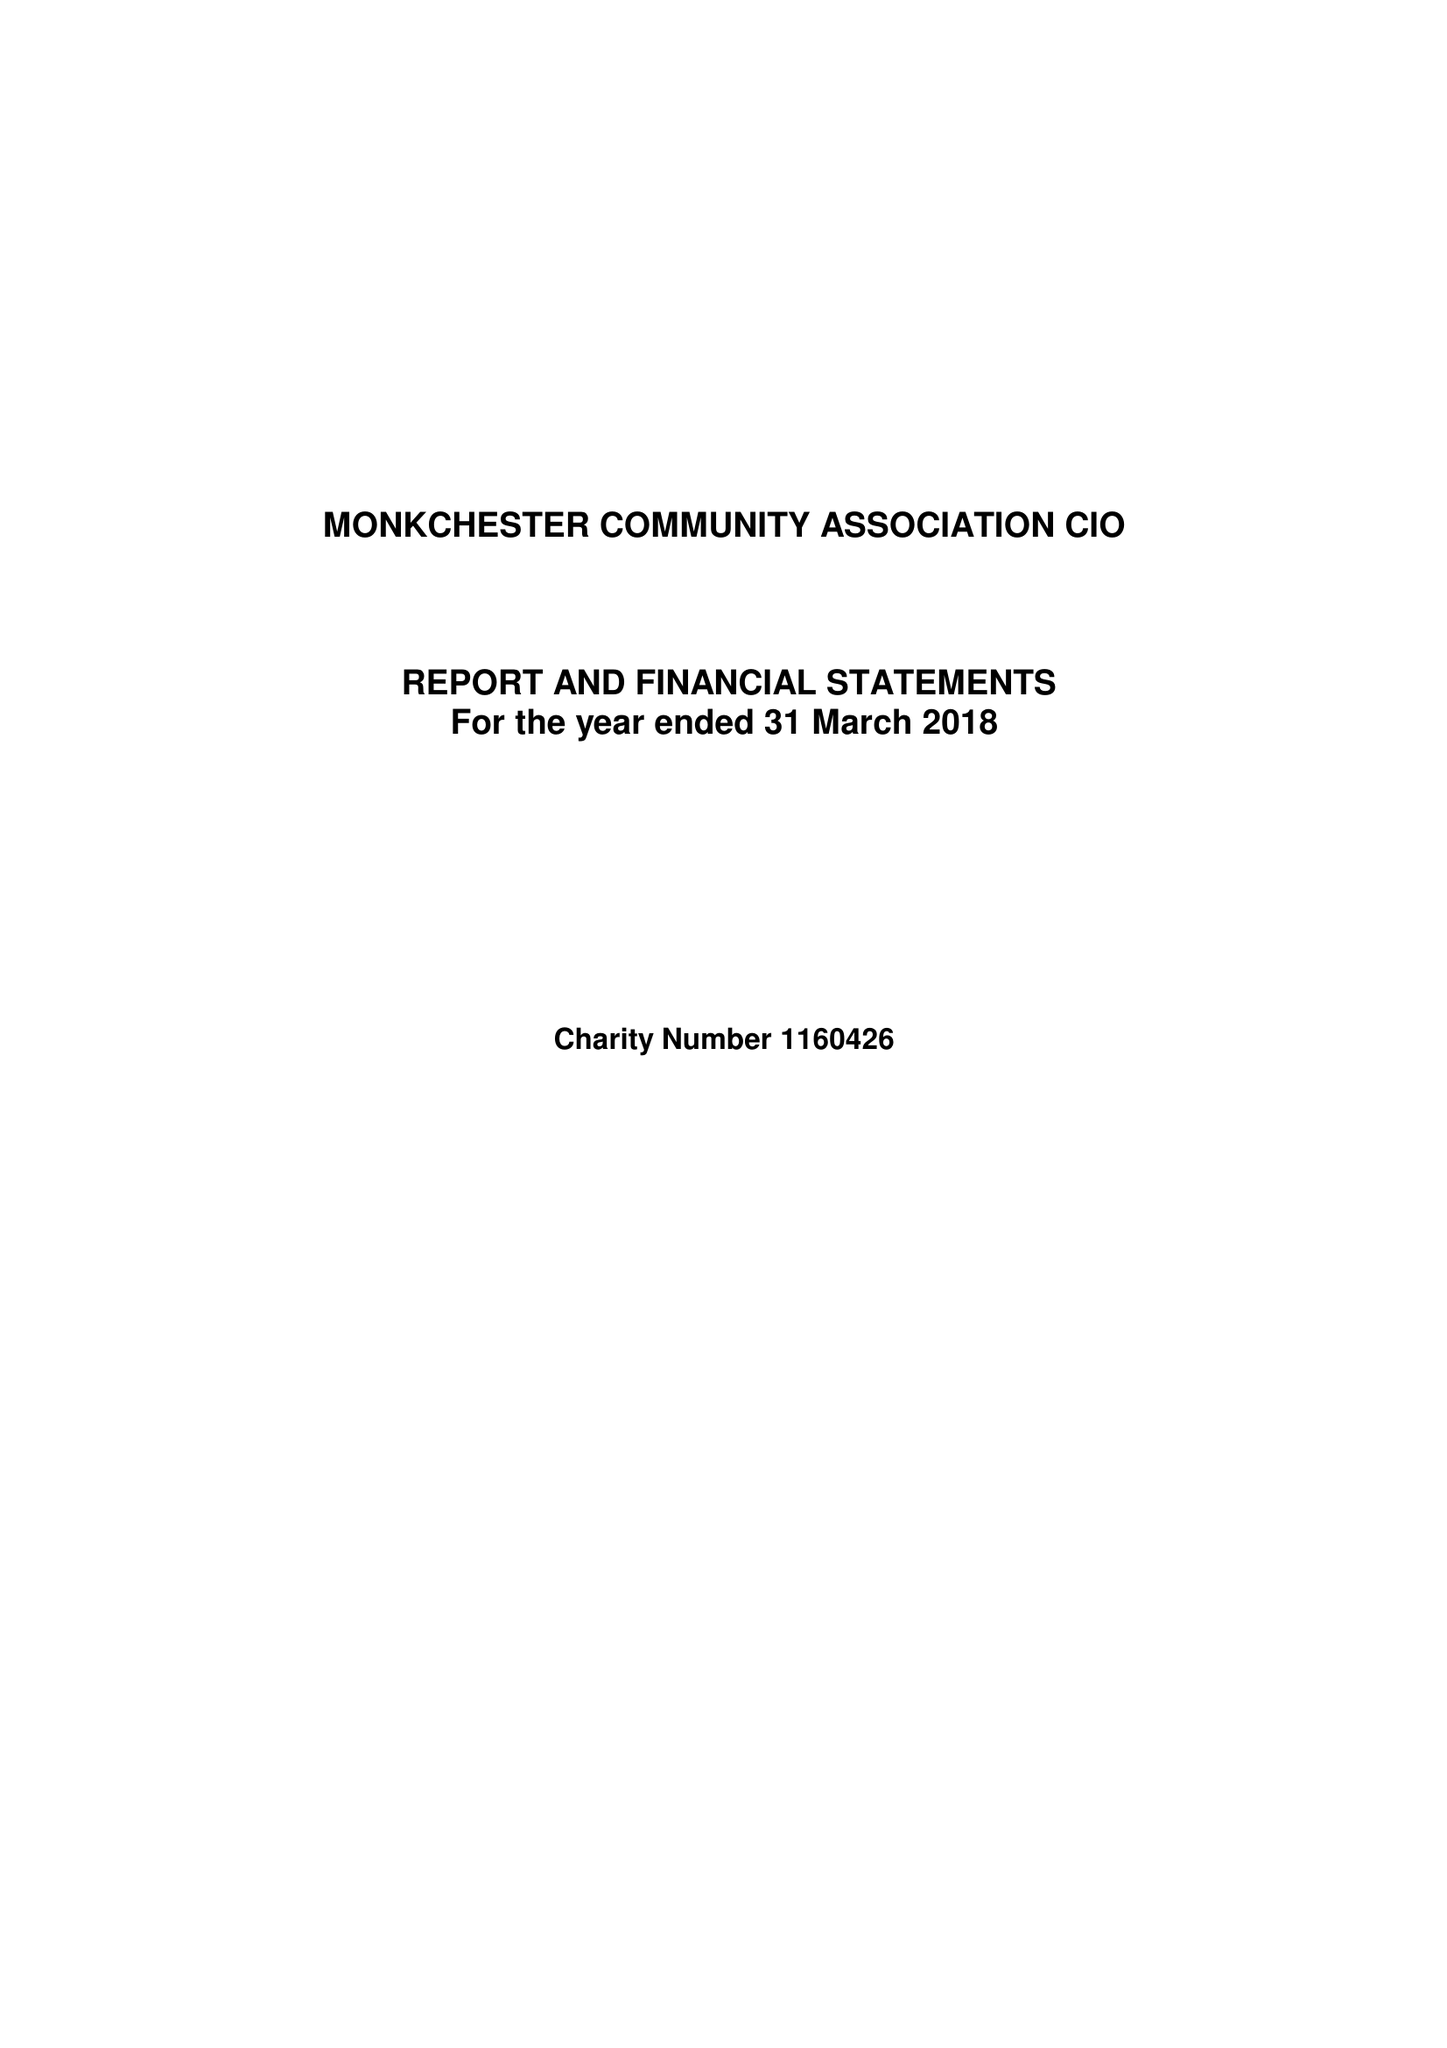What is the value for the report_date?
Answer the question using a single word or phrase. 2018-03-31 